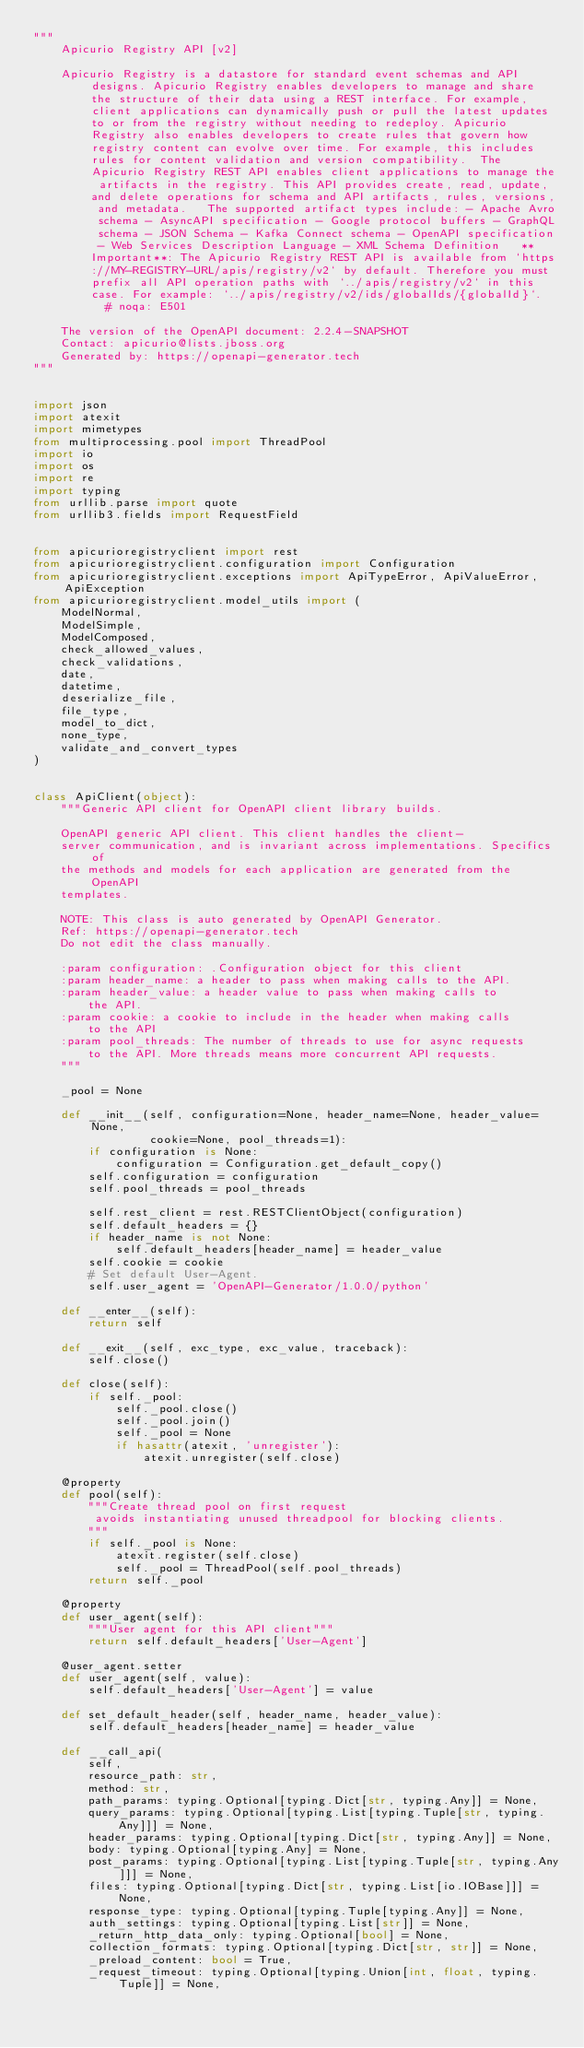<code> <loc_0><loc_0><loc_500><loc_500><_Python_>"""
    Apicurio Registry API [v2]

    Apicurio Registry is a datastore for standard event schemas and API designs. Apicurio Registry enables developers to manage and share the structure of their data using a REST interface. For example, client applications can dynamically push or pull the latest updates to or from the registry without needing to redeploy. Apicurio Registry also enables developers to create rules that govern how registry content can evolve over time. For example, this includes rules for content validation and version compatibility.  The Apicurio Registry REST API enables client applications to manage the artifacts in the registry. This API provides create, read, update, and delete operations for schema and API artifacts, rules, versions, and metadata.   The supported artifact types include: - Apache Avro schema - AsyncAPI specification - Google protocol buffers - GraphQL schema - JSON Schema - Kafka Connect schema - OpenAPI specification - Web Services Description Language - XML Schema Definition   **Important**: The Apicurio Registry REST API is available from `https://MY-REGISTRY-URL/apis/registry/v2` by default. Therefore you must prefix all API operation paths with `../apis/registry/v2` in this case. For example: `../apis/registry/v2/ids/globalIds/{globalId}`.   # noqa: E501

    The version of the OpenAPI document: 2.2.4-SNAPSHOT
    Contact: apicurio@lists.jboss.org
    Generated by: https://openapi-generator.tech
"""


import json
import atexit
import mimetypes
from multiprocessing.pool import ThreadPool
import io
import os
import re
import typing
from urllib.parse import quote
from urllib3.fields import RequestField


from apicurioregistryclient import rest
from apicurioregistryclient.configuration import Configuration
from apicurioregistryclient.exceptions import ApiTypeError, ApiValueError, ApiException
from apicurioregistryclient.model_utils import (
    ModelNormal,
    ModelSimple,
    ModelComposed,
    check_allowed_values,
    check_validations,
    date,
    datetime,
    deserialize_file,
    file_type,
    model_to_dict,
    none_type,
    validate_and_convert_types
)


class ApiClient(object):
    """Generic API client for OpenAPI client library builds.

    OpenAPI generic API client. This client handles the client-
    server communication, and is invariant across implementations. Specifics of
    the methods and models for each application are generated from the OpenAPI
    templates.

    NOTE: This class is auto generated by OpenAPI Generator.
    Ref: https://openapi-generator.tech
    Do not edit the class manually.

    :param configuration: .Configuration object for this client
    :param header_name: a header to pass when making calls to the API.
    :param header_value: a header value to pass when making calls to
        the API.
    :param cookie: a cookie to include in the header when making calls
        to the API
    :param pool_threads: The number of threads to use for async requests
        to the API. More threads means more concurrent API requests.
    """

    _pool = None

    def __init__(self, configuration=None, header_name=None, header_value=None,
                 cookie=None, pool_threads=1):
        if configuration is None:
            configuration = Configuration.get_default_copy()
        self.configuration = configuration
        self.pool_threads = pool_threads

        self.rest_client = rest.RESTClientObject(configuration)
        self.default_headers = {}
        if header_name is not None:
            self.default_headers[header_name] = header_value
        self.cookie = cookie
        # Set default User-Agent.
        self.user_agent = 'OpenAPI-Generator/1.0.0/python'

    def __enter__(self):
        return self

    def __exit__(self, exc_type, exc_value, traceback):
        self.close()

    def close(self):
        if self._pool:
            self._pool.close()
            self._pool.join()
            self._pool = None
            if hasattr(atexit, 'unregister'):
                atexit.unregister(self.close)

    @property
    def pool(self):
        """Create thread pool on first request
         avoids instantiating unused threadpool for blocking clients.
        """
        if self._pool is None:
            atexit.register(self.close)
            self._pool = ThreadPool(self.pool_threads)
        return self._pool

    @property
    def user_agent(self):
        """User agent for this API client"""
        return self.default_headers['User-Agent']

    @user_agent.setter
    def user_agent(self, value):
        self.default_headers['User-Agent'] = value

    def set_default_header(self, header_name, header_value):
        self.default_headers[header_name] = header_value

    def __call_api(
        self,
        resource_path: str,
        method: str,
        path_params: typing.Optional[typing.Dict[str, typing.Any]] = None,
        query_params: typing.Optional[typing.List[typing.Tuple[str, typing.Any]]] = None,
        header_params: typing.Optional[typing.Dict[str, typing.Any]] = None,
        body: typing.Optional[typing.Any] = None,
        post_params: typing.Optional[typing.List[typing.Tuple[str, typing.Any]]] = None,
        files: typing.Optional[typing.Dict[str, typing.List[io.IOBase]]] = None,
        response_type: typing.Optional[typing.Tuple[typing.Any]] = None,
        auth_settings: typing.Optional[typing.List[str]] = None,
        _return_http_data_only: typing.Optional[bool] = None,
        collection_formats: typing.Optional[typing.Dict[str, str]] = None,
        _preload_content: bool = True,
        _request_timeout: typing.Optional[typing.Union[int, float, typing.Tuple]] = None,</code> 